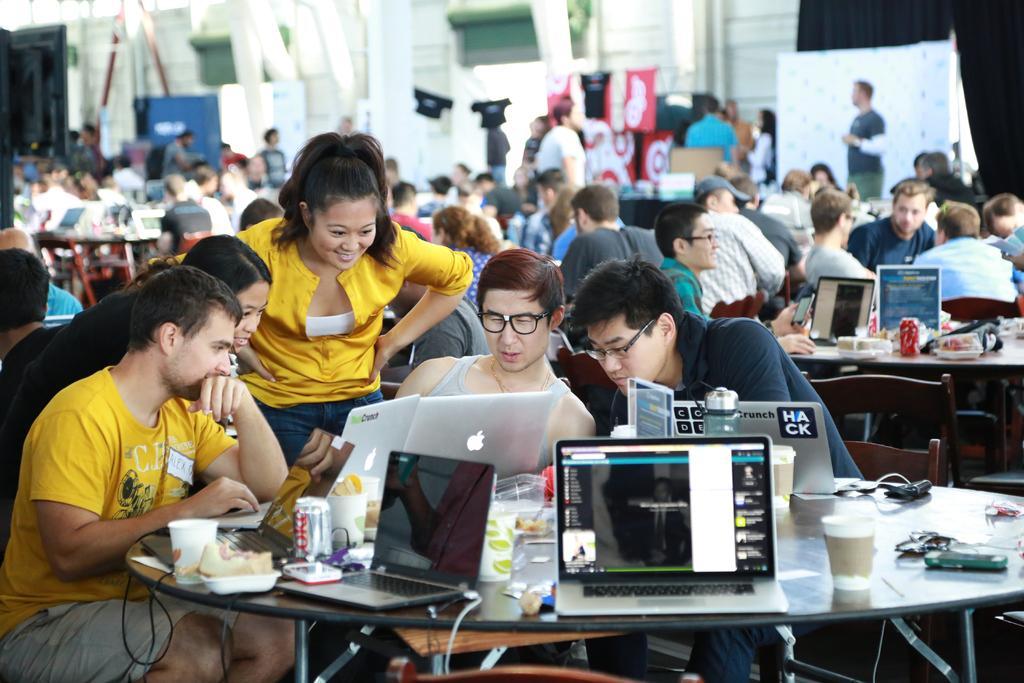Please provide a concise description of this image. In the image we can see there are many people sitting and some of them are standing. This is a table on which laptops, can, snacks and glasses are kept. This is a chair. 